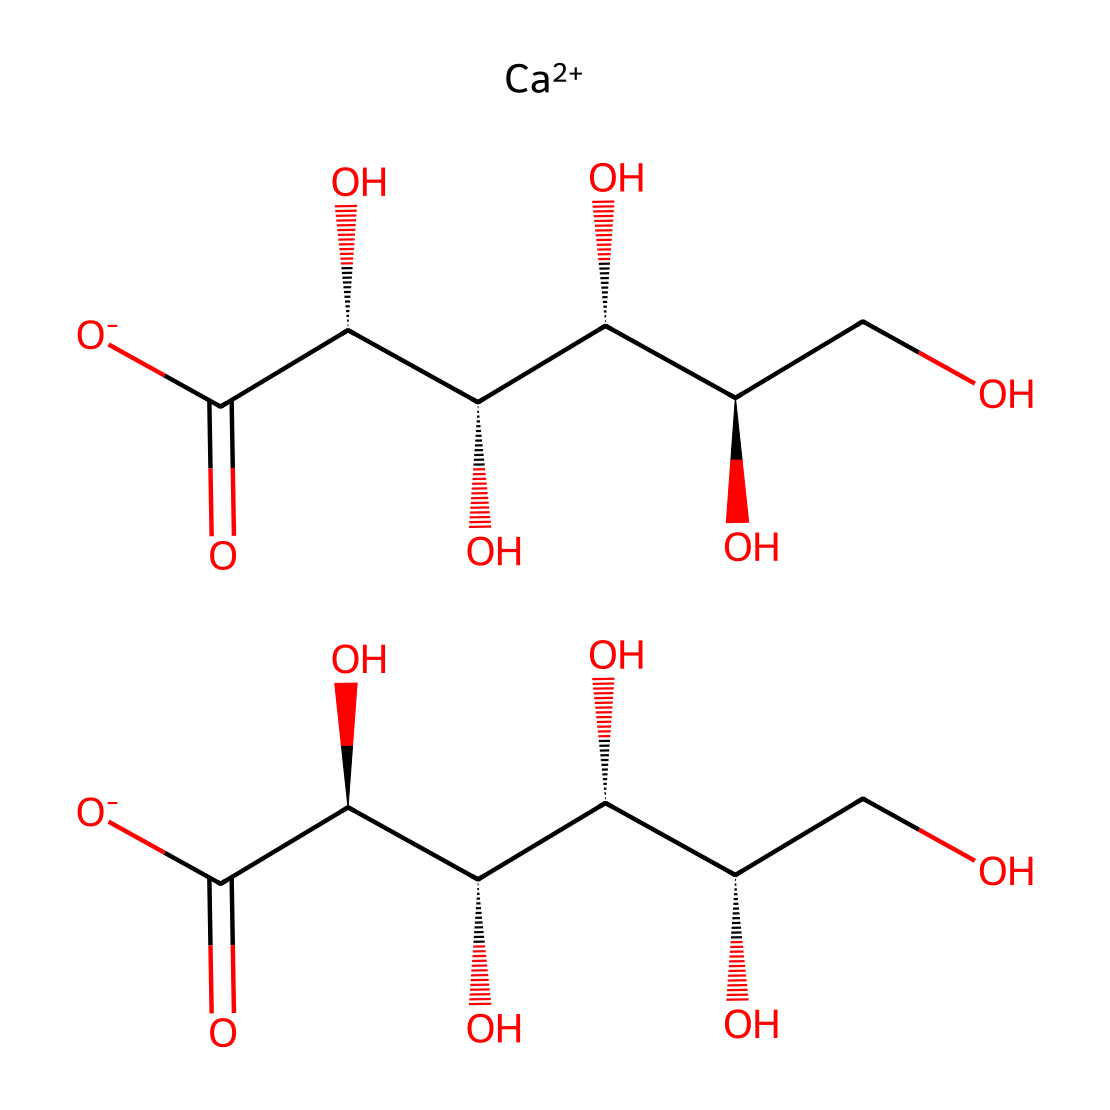What is the chemical name of this compound? The structure presented represents calcium gluconate, as it contains a calcium ion and the gluconate moiety that consists of multiple hydroxyl and carboxyl groups.
Answer: calcium gluconate How many total carbon atoms are in calcium gluconate? By examining the structure, we can count the carbon atoms in both gluconate groups present in the molecule. Each gluconate has six carbon atoms, and there are two gluconate groups leading to a total of twelve.
Answer: twelve What functional groups are present in calcium gluconate? Calcium gluconate contains carboxylic acid groups (–COOH) and hydroxyl groups (–OH), which can be identified in the structure by their characteristic bonding and arrangements of atoms.
Answer: hydroxyl and carboxylic acid What is the oxidation state of calcium in this compound? In calcium gluconate, calcium is shown as Ca++ which indicates it has a +2 oxidation state, reflecting its role as a cation that balances the negatively charged gluconate.
Answer: +2 How many chiral centers are present in the gluconate moiety of calcium gluconate? By analyzing the configuration of the carbon atoms in the gluconate chains, we can find four chiral centers, as indicated by the presence of four carbons attached to four different substituents.
Answer: four What is the main role of calcium gluconate as an electrolyte? Calcium gluconate primarily serves to replenish calcium levels in the body, particularly important for bone health and muscle function, which is evident from its composition as an electrolyte.
Answer: replenish calcium levels 